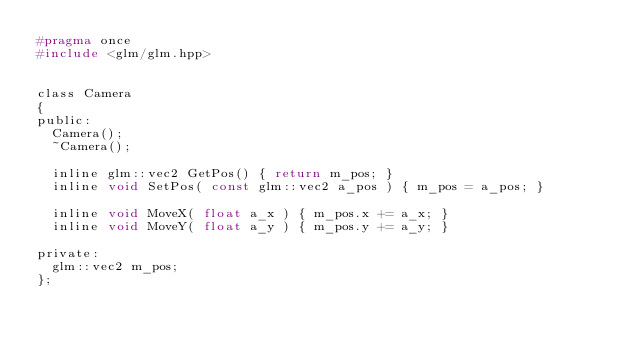Convert code to text. <code><loc_0><loc_0><loc_500><loc_500><_C_>#pragma once
#include <glm/glm.hpp>


class Camera
{
public:
  Camera();
  ~Camera();

  inline glm::vec2 GetPos() { return m_pos; }
  inline void SetPos( const glm::vec2 a_pos ) { m_pos = a_pos; }

  inline void MoveX( float a_x ) { m_pos.x += a_x; }
  inline void MoveY( float a_y ) { m_pos.y += a_y; }

private:
  glm::vec2 m_pos;
};

</code> 